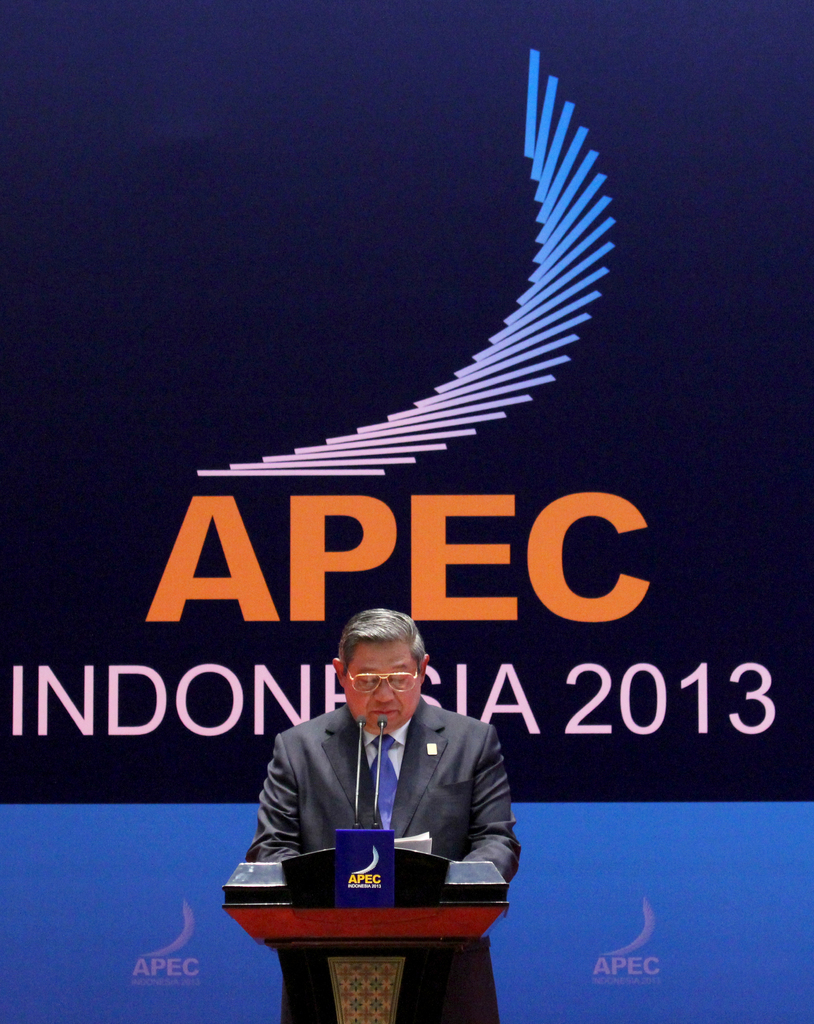What imagery in the background suggests the tone or theme of the conference? The background features a dynamic, upward-pointing graphic that visually represents growth and progress, aligning with APEC's focus on economic dynamism. The use of a sleek, modern design and a soothing blue color palette suggests a theme of calm, reasoned discourse aimed at fostering cooperation and forward-looking policies among the member nations. 